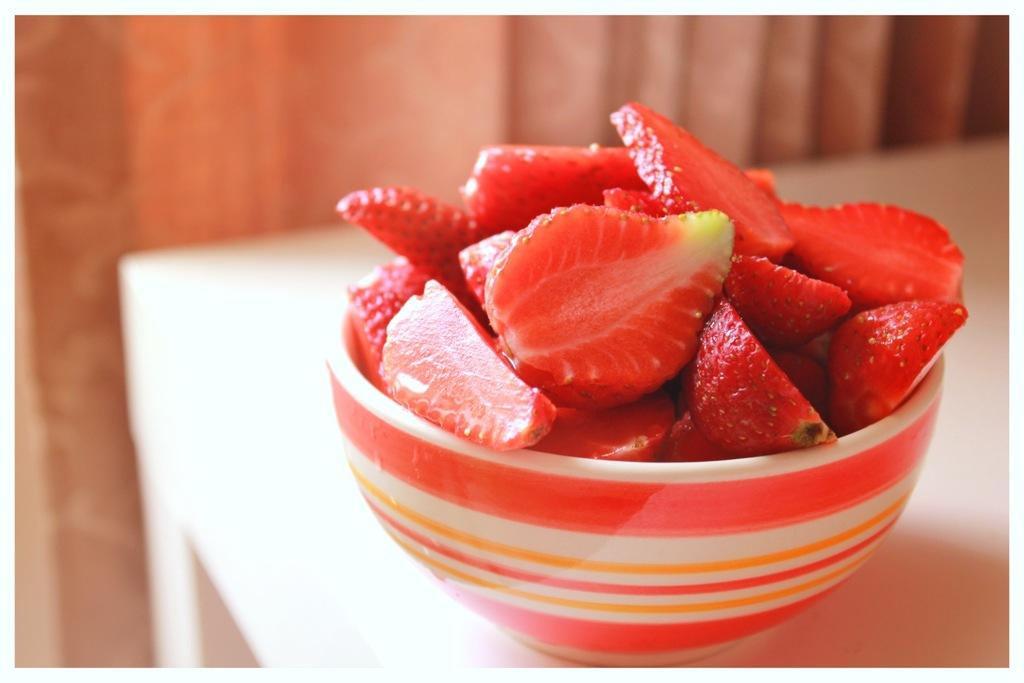What is the main piece of furniture in the image? There is a table in the image. What is placed on the table? There is a bowl on the table. What is inside the bowl? The bowl contains strawberry pieces. What type of paint is being used to create the strawberry pieces in the image? There is no paint present in the image; the strawberry pieces are real fruit. 